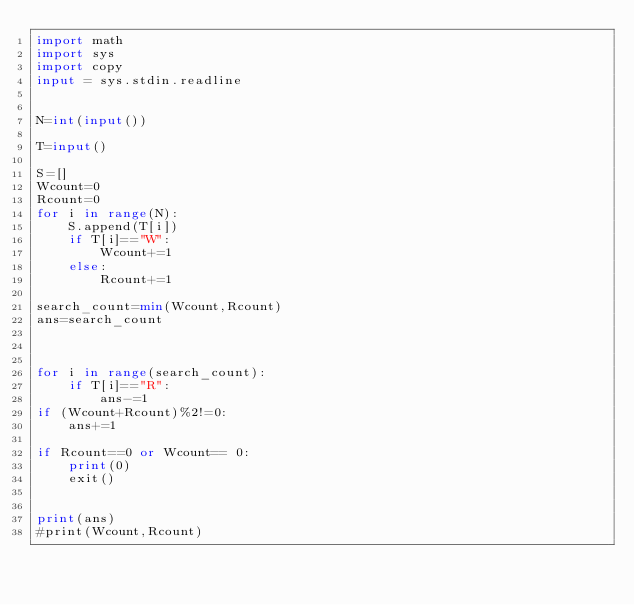<code> <loc_0><loc_0><loc_500><loc_500><_Python_>import math
import sys
import copy
input = sys.stdin.readline


N=int(input())

T=input()

S=[]
Wcount=0
Rcount=0
for i in range(N):
    S.append(T[i])
    if T[i]=="W":
        Wcount+=1
    else:
        Rcount+=1

search_count=min(Wcount,Rcount)
ans=search_count



for i in range(search_count):
    if T[i]=="R":
        ans-=1
if (Wcount+Rcount)%2!=0:
    ans+=1

if Rcount==0 or Wcount== 0:
    print(0)
    exit()


print(ans)
#print(Wcount,Rcount)</code> 